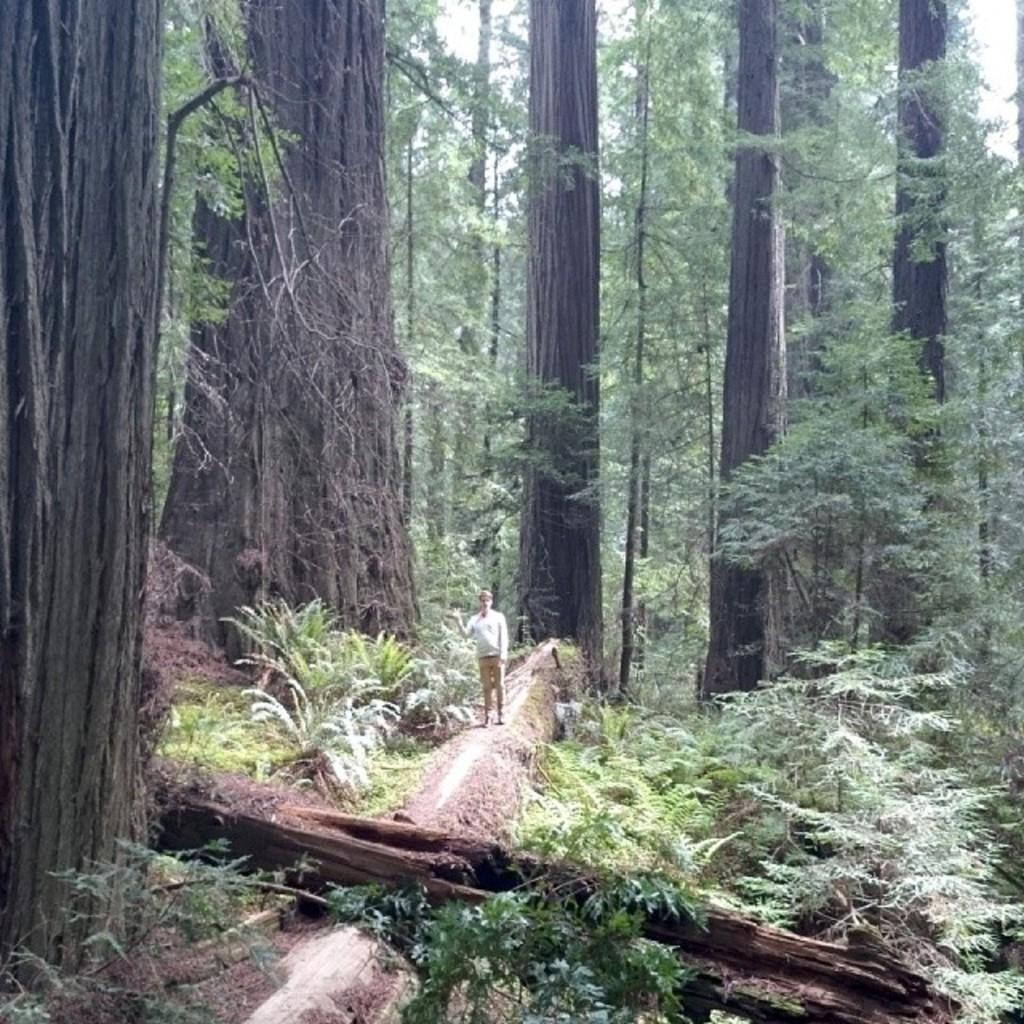How would you summarize this image in a sentence or two? In the center of the image, we can see a person standing and in the background, there are many trees. 